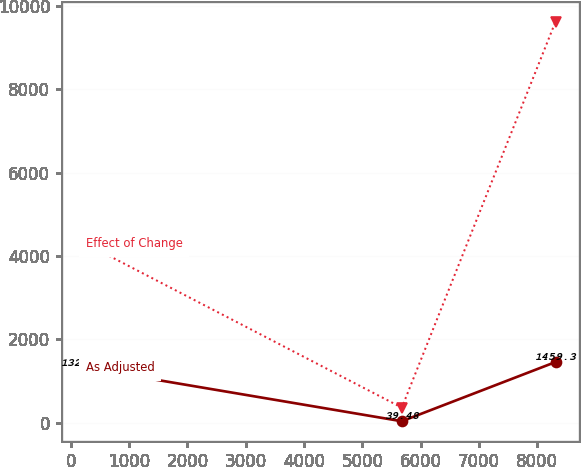Convert chart. <chart><loc_0><loc_0><loc_500><loc_500><line_chart><ecel><fcel>As Adjusted<fcel>Effect of Change<nl><fcel>250.72<fcel>1320.49<fcel>4299.54<nl><fcel>5677.51<fcel>39.48<fcel>365.65<nl><fcel>8314.8<fcel>1459.3<fcel>9622.08<nl></chart> 